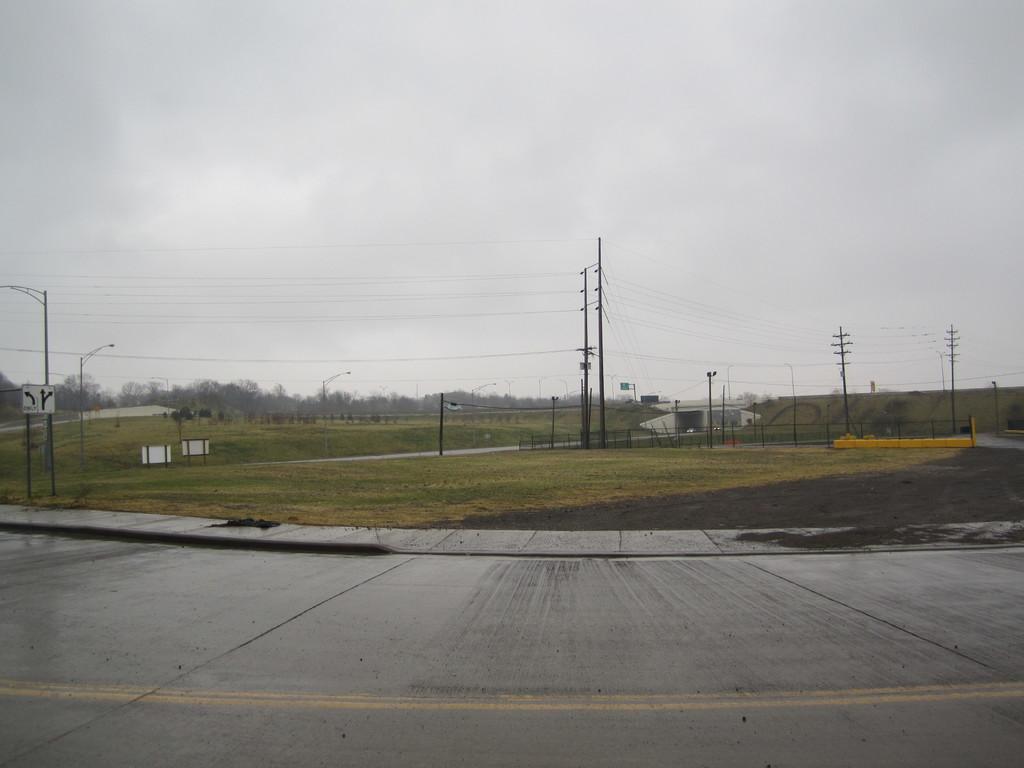Describe this image in one or two sentences. In this image we can see some roads, some poles with boards, some lights with poles, some current poles with wires, some objects are on the surface, one building, some trees, bushes, plants and grass on the surface. At the top there is the cloudy sky. 